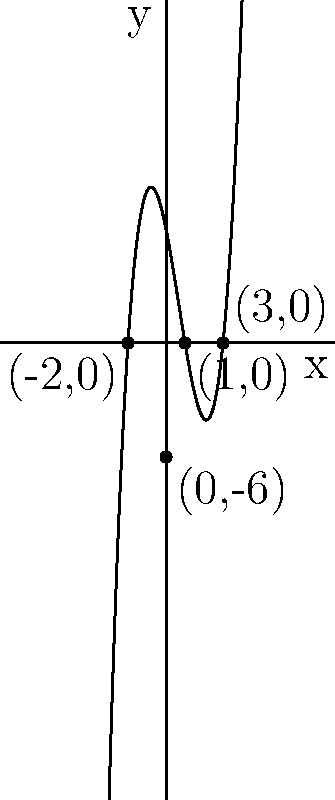As a student who values education, analyze the graph of the polynomial function shown above. Identify the x-intercepts and y-intercept of this function. How do these intercepts relate to the roots of the polynomial equation? Let's approach this step-by-step:

1) X-intercepts:
   - X-intercepts are the points where the graph crosses the x-axis.
   - From the graph, we can see three x-intercepts:
     a) $(-2,0)$
     b) $(1,0)$
     c) $(3,0)$

2) Y-intercept:
   - The y-intercept is the point where the graph crosses the y-axis.
   - From the graph, we can see that the y-intercept is $(0,-6)$.

3) Relation to roots:
   - The x-coordinates of the x-intercepts are the roots of the polynomial equation.
   - This means that when $x = -2$, $x = 1$, or $x = 3$, the polynomial equals zero.

4) Polynomial form:
   - Given this information, we can deduce that the polynomial is of the form:
     $f(x) = a(x+2)(x-1)(x-3)$
   - Where $a$ is a constant that can be determined using the y-intercept.

5) Educational significance:
   - Understanding these concepts is crucial in algebra and calculus, forming the foundation for more advanced mathematical analysis.
Answer: X-intercepts: $(-2,0)$, $(1,0)$, $(3,0)$; Y-intercept: $(0,-6)$; X-coordinates of x-intercepts are roots of the polynomial equation. 